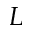Convert formula to latex. <formula><loc_0><loc_0><loc_500><loc_500>L</formula> 